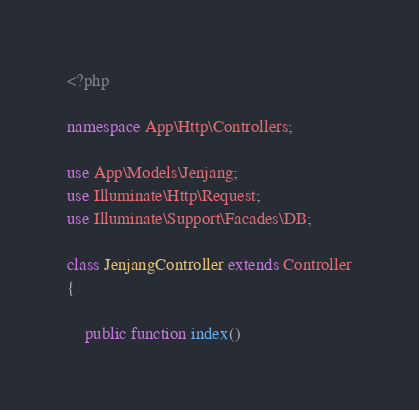<code> <loc_0><loc_0><loc_500><loc_500><_PHP_><?php

namespace App\Http\Controllers;

use App\Models\Jenjang;
use Illuminate\Http\Request;
use Illuminate\Support\Facades\DB;

class JenjangController extends Controller
{

    public function index()</code> 